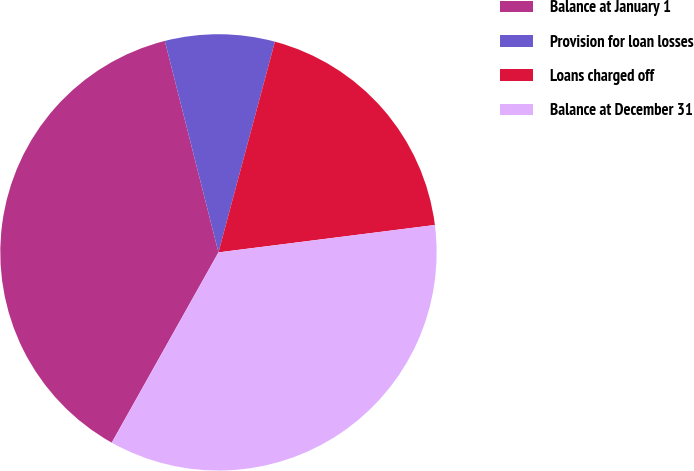Convert chart. <chart><loc_0><loc_0><loc_500><loc_500><pie_chart><fcel>Balance at January 1<fcel>Provision for loan losses<fcel>Loans charged off<fcel>Balance at December 31<nl><fcel>37.91%<fcel>8.12%<fcel>18.83%<fcel>35.14%<nl></chart> 